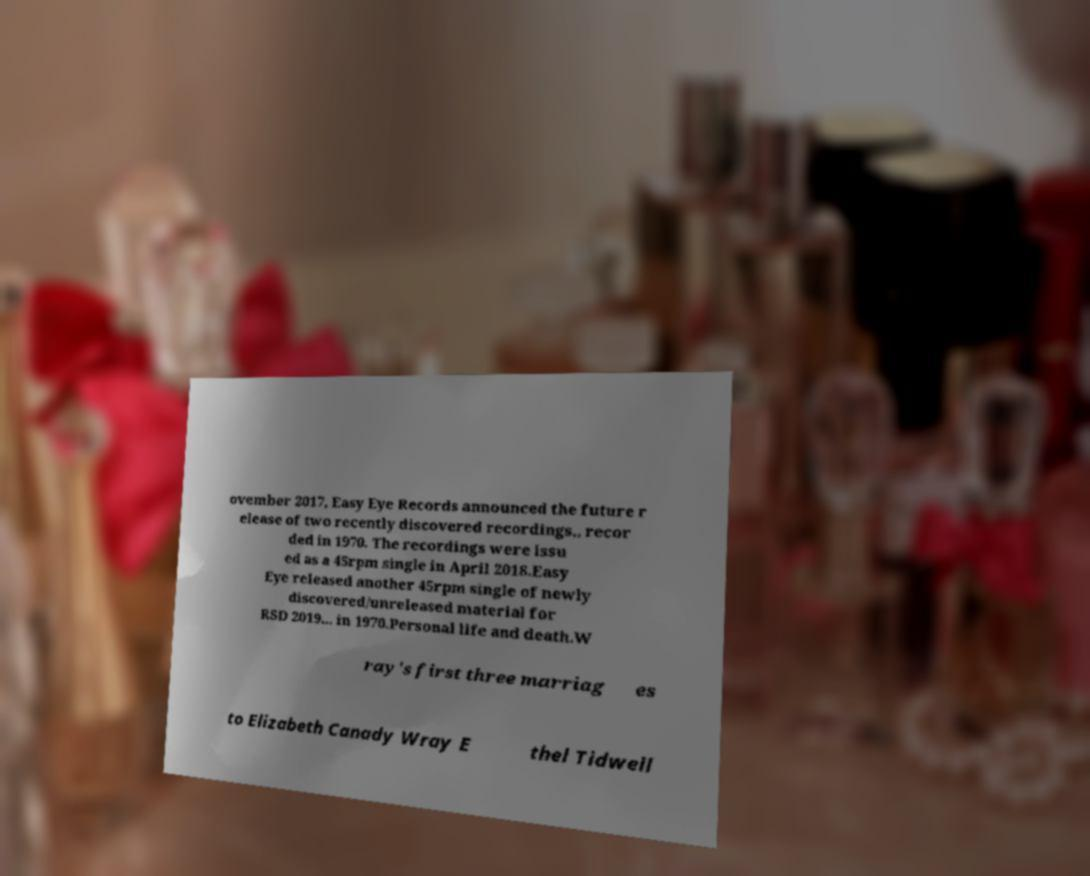Could you extract and type out the text from this image? ovember 2017, Easy Eye Records announced the future r elease of two recently discovered recordings,, recor ded in 1970. The recordings were issu ed as a 45rpm single in April 2018.Easy Eye released another 45rpm single of newly discovered/unreleased material for RSD 2019... in 1970.Personal life and death.W ray's first three marriag es to Elizabeth Canady Wray E thel Tidwell 